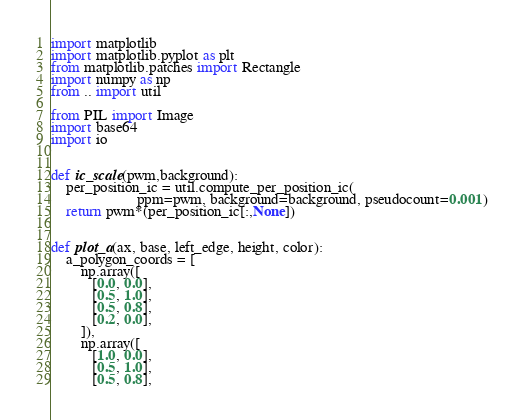<code> <loc_0><loc_0><loc_500><loc_500><_Python_>import matplotlib
import matplotlib.pyplot as plt
from matplotlib.patches import Rectangle
import numpy as np
from .. import util

from PIL import Image
import base64
import io


def ic_scale(pwm,background):
    per_position_ic = util.compute_per_position_ic(
                       ppm=pwm, background=background, pseudocount=0.001)
    return pwm*(per_position_ic[:,None])


def plot_a(ax, base, left_edge, height, color):
    a_polygon_coords = [
        np.array([
           [0.0, 0.0],
           [0.5, 1.0],
           [0.5, 0.8],
           [0.2, 0.0],
        ]),
        np.array([
           [1.0, 0.0],
           [0.5, 1.0],
           [0.5, 0.8],</code> 